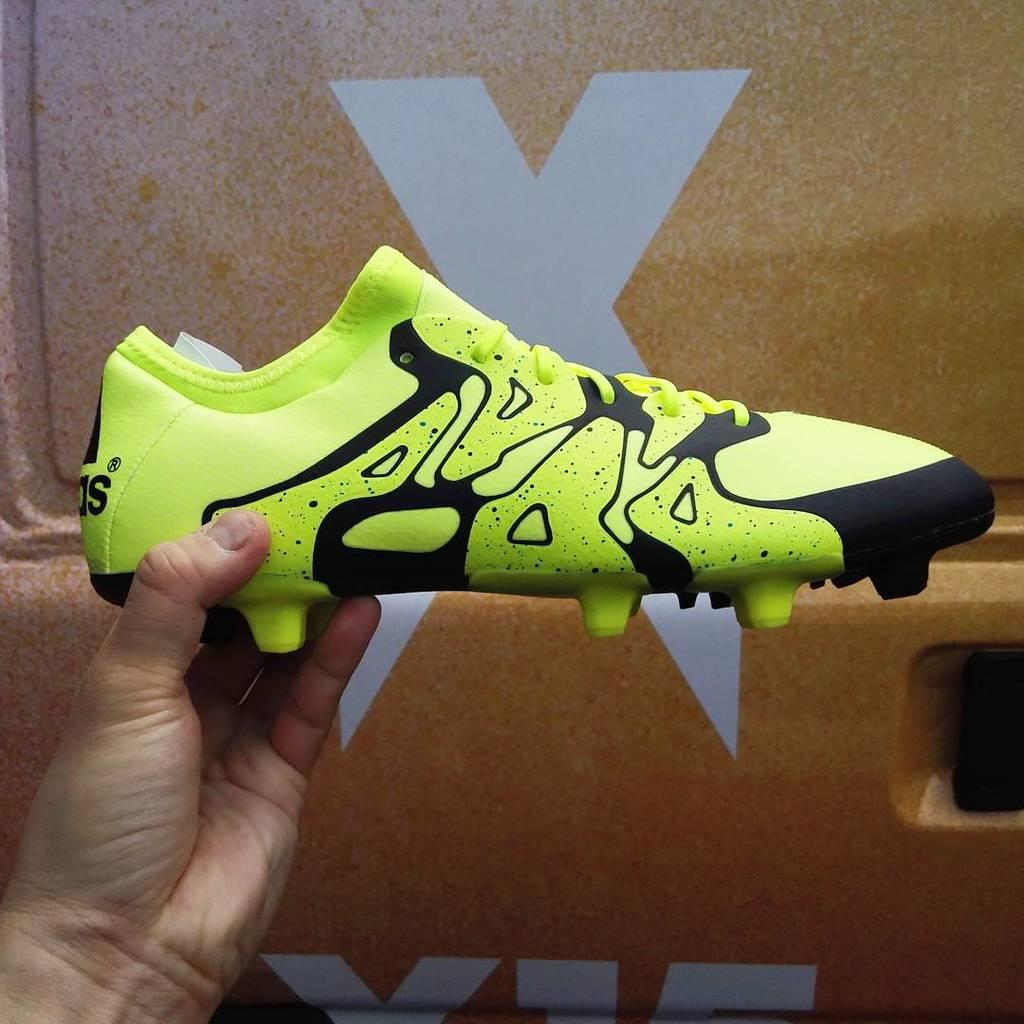What is the person's hand holding in the image? The person's hand is holding a green shoe in the image. Is there any text associated with the shoe or nearby? Yes, there is text written on the shoe or nearby. What can be seen in the background of the image? There is a logo visible in the background. Can you see a bee buzzing around the shoe in the image? No, there is no bee present in the image. Is there a stream visible in the background of the image? No, there is no stream visible in the image; only a logo is present in the background. 